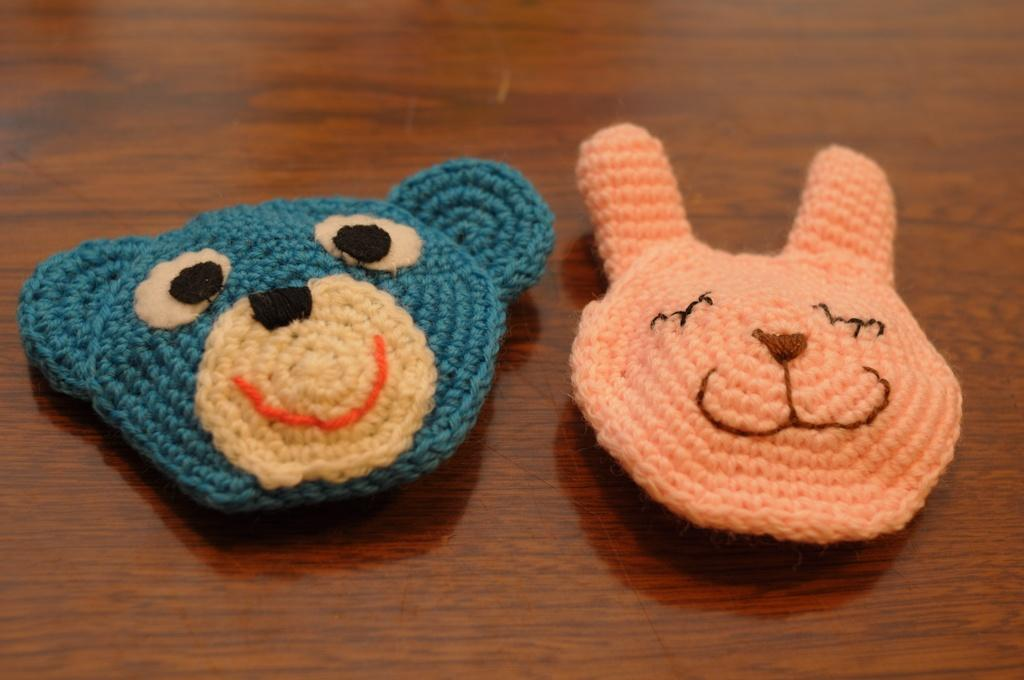What type of clothes are visible in the image? There are woolen clothes in the image. Where are the woolen clothes placed? The woolen clothes are on a wooden surface. What type of roof is visible in the image? There is no roof visible in the image; the focus is on the woolen clothes and their location. We begin by identifying the main subject, which is the woolen clothes. Then, we describe their location, which is on a wooden surface. Each question is designed to elicit a specific detail about the image that is known from the provided facts. The absurd question is about a topic that is not present in the image, specifically a roof. 